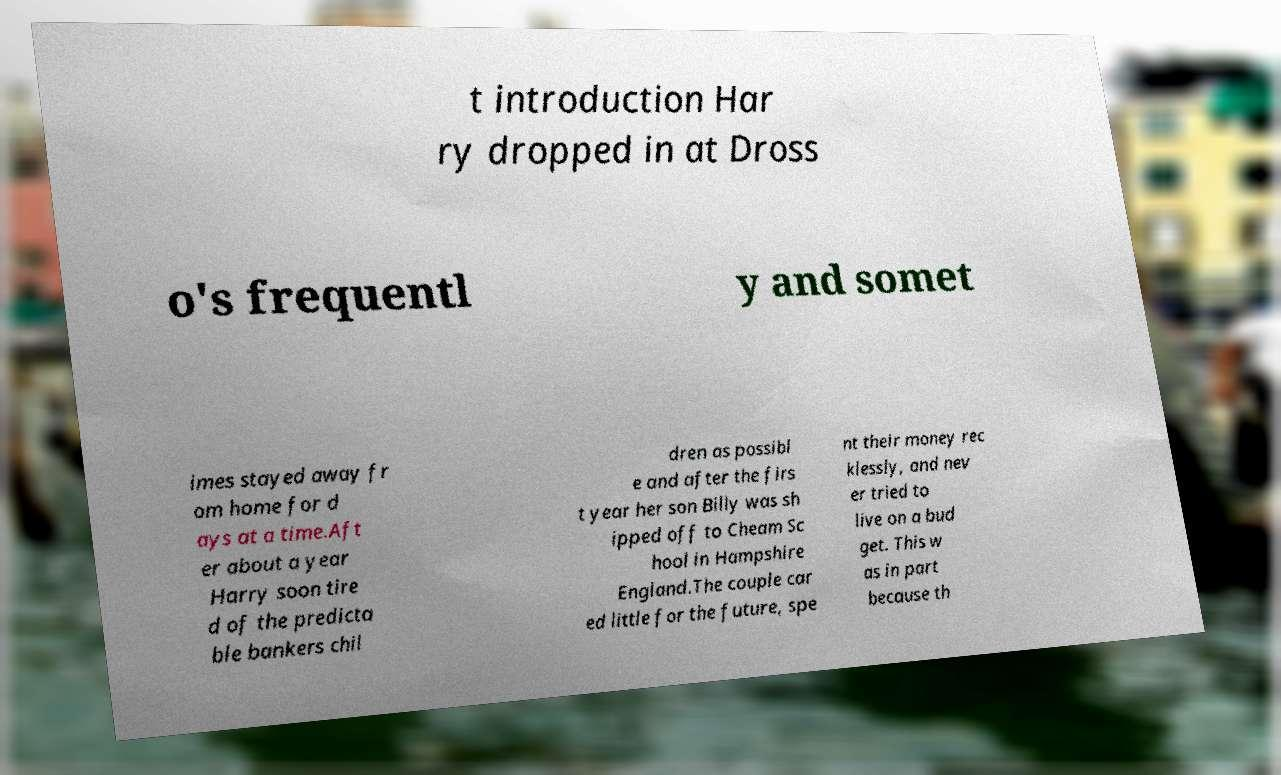I need the written content from this picture converted into text. Can you do that? t introduction Har ry dropped in at Dross o's frequentl y and somet imes stayed away fr om home for d ays at a time.Aft er about a year Harry soon tire d of the predicta ble bankers chil dren as possibl e and after the firs t year her son Billy was sh ipped off to Cheam Sc hool in Hampshire England.The couple car ed little for the future, spe nt their money rec klessly, and nev er tried to live on a bud get. This w as in part because th 